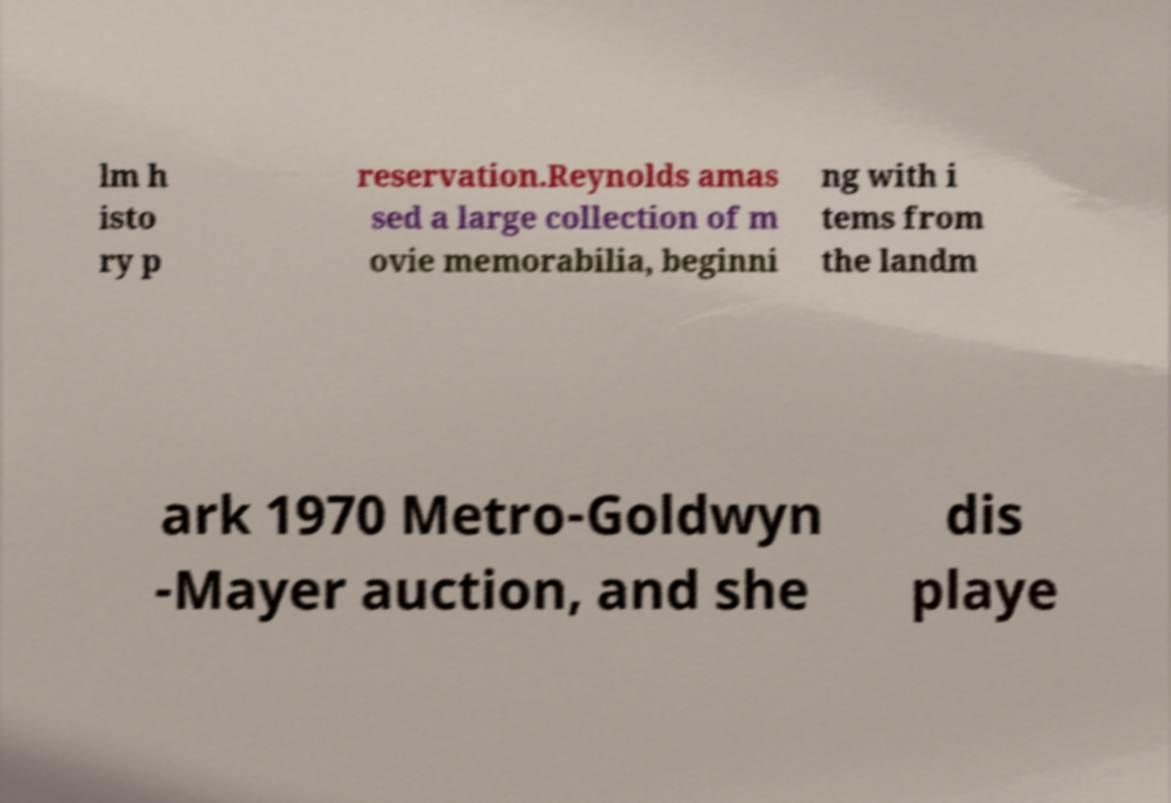Could you extract and type out the text from this image? lm h isto ry p reservation.Reynolds amas sed a large collection of m ovie memorabilia, beginni ng with i tems from the landm ark 1970 Metro-Goldwyn -Mayer auction, and she dis playe 